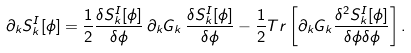Convert formula to latex. <formula><loc_0><loc_0><loc_500><loc_500>\partial _ { k } S _ { k } ^ { I } [ \phi ] = { \frac { 1 } { 2 } } { \frac { \delta S _ { k } ^ { I } [ \phi ] } { \delta \phi } } \, \partial _ { k } G _ { k } \, { \frac { \delta S _ { k } ^ { I } [ \phi ] } { \delta \phi } } - { \frac { 1 } { 2 } } { T r } \left [ \partial _ { k } G _ { k } { \frac { \delta ^ { 2 } S _ { k } ^ { I } [ \phi ] } { \delta \phi \delta \phi } } \right ] .</formula> 